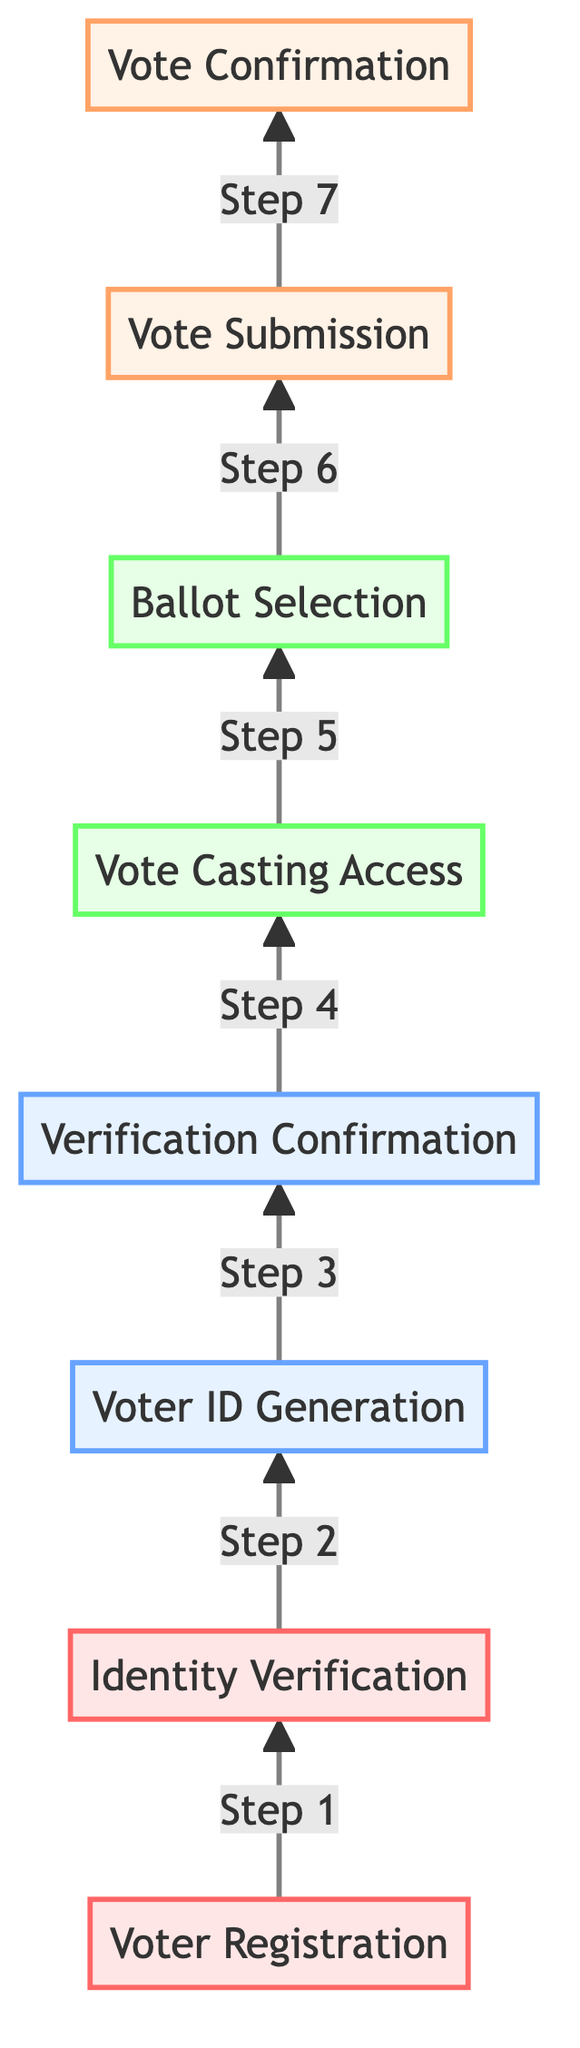What is the first step in the voter verification process? The diagram shows that the first step is "Voter Registration," which is the first node at the bottom of the flowchart.
Answer: Voter Registration How many steps are there in total in the diagram? The diagram lists eight distinct steps, each representing a part of the voter verification process, from registration to vote confirmation.
Answer: Eight What is the last step in the process? The last step in the diagram is "Vote Confirmation," which is the final node at the top of the flowchart.
Answer: Vote Confirmation Which step comes after "Identity Verification"? According to the flowchart, after "Identity Verification," the next step is "Voter ID Generation," indicating the progression in the verification process.
Answer: Voter ID Generation What does the "Vote Submission" step entail? The diagram describes "Vote Submission" as the step where the completed ballot is securely submitted and encrypted.
Answer: Completed ballot submitted What is the relationship between "Voter ID Generation" and "Verification Confirmation"? The flowchart indicates that "Voter ID Generation" occurs directly before "Verification Confirmation," meaning that the generation of the Voter ID must happen first to confirm receipt.
Answer: Sequential How many nodes are highlighted in the second color class? The diagram shows four nodes highlighted in the second color class, indicating those steps involve the verification process.
Answer: Four What must a voter do after receiving the Voter ID? The flowchart clearly states that after receiving the Voter ID, the voter must confirm receipt through a secure verification link.
Answer: Confirm receipt What action is taken during "Ballot Selection"? The diagram indicates that during "Ballot Selection," the voter selects candidates and measures on the electronic ballot, which directly describes the action for this step.
Answer: Select candidates and measures 